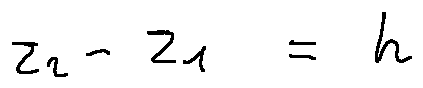Convert formula to latex. <formula><loc_0><loc_0><loc_500><loc_500>z _ { 2 } - z _ { 1 } = h</formula> 